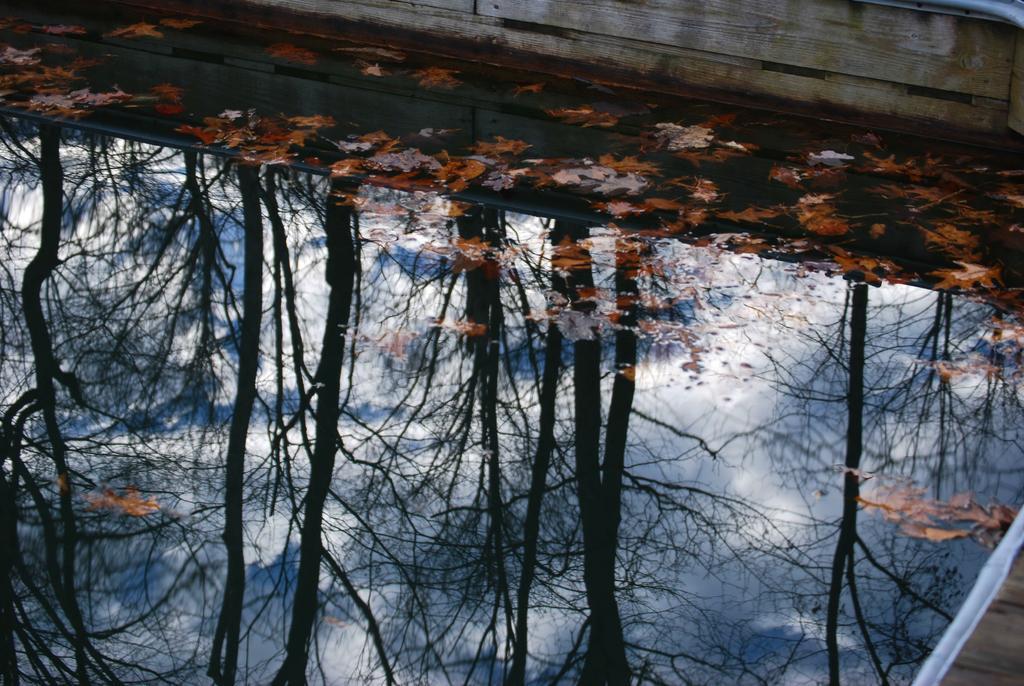In one or two sentences, can you explain what this image depicts? In this image we an see the water, leaves and we can also see the trees in reflection. 